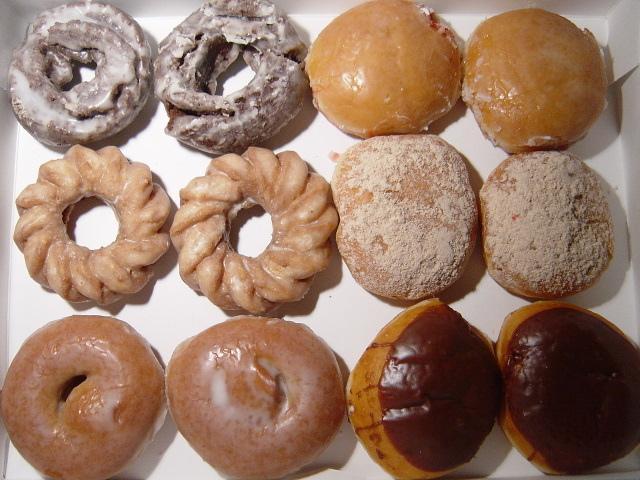How many varieties of donuts are there?
Give a very brief answer. 6. How many doughnuts have chocolate frosting?
Give a very brief answer. 2. How many donuts can you see?
Give a very brief answer. 12. 